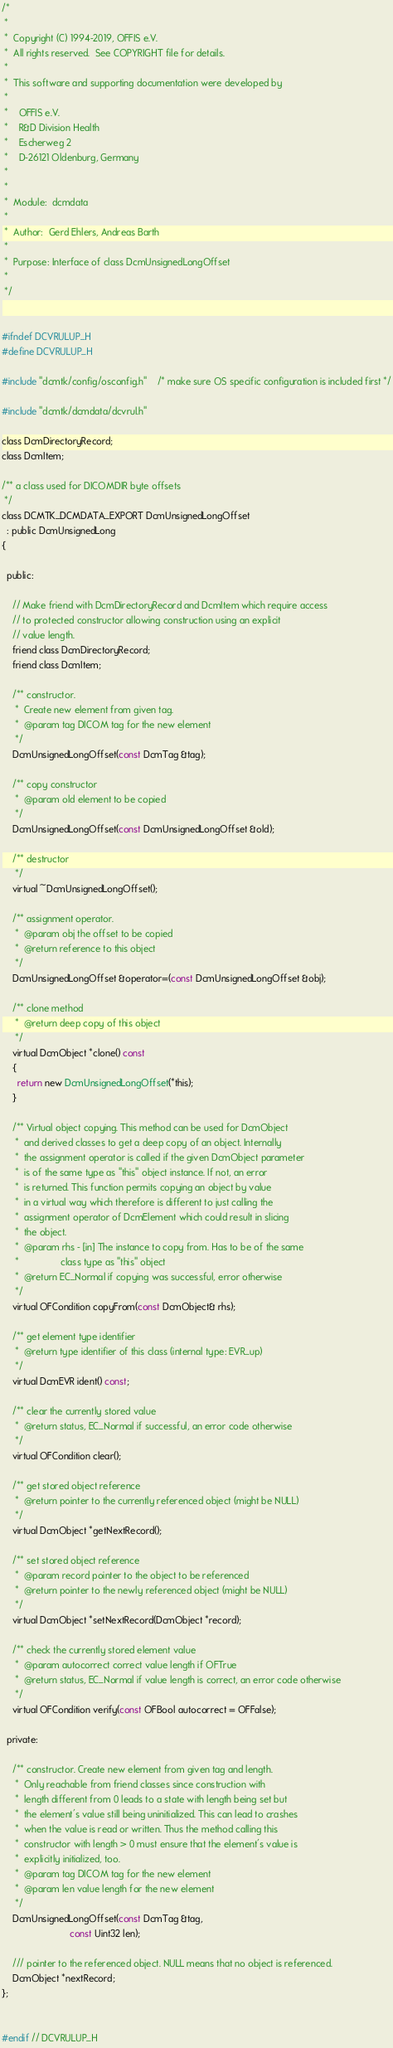<code> <loc_0><loc_0><loc_500><loc_500><_C_>/*
 *
 *  Copyright (C) 1994-2019, OFFIS e.V.
 *  All rights reserved.  See COPYRIGHT file for details.
 *
 *  This software and supporting documentation were developed by
 *
 *    OFFIS e.V.
 *    R&D Division Health
 *    Escherweg 2
 *    D-26121 Oldenburg, Germany
 *
 *
 *  Module:  dcmdata
 *
 *  Author:  Gerd Ehlers, Andreas Barth
 *
 *  Purpose: Interface of class DcmUnsignedLongOffset
 *
 */


#ifndef DCVRULUP_H
#define DCVRULUP_H

#include "dcmtk/config/osconfig.h"    /* make sure OS specific configuration is included first */

#include "dcmtk/dcmdata/dcvrul.h"

class DcmDirectoryRecord;
class DcmItem;

/** a class used for DICOMDIR byte offsets
 */
class DCMTK_DCMDATA_EXPORT DcmUnsignedLongOffset
  : public DcmUnsignedLong
{

  public:

    // Make friend with DcmDirectoryRecord and DcmItem which require access
    // to protected constructor allowing construction using an explicit
    // value length.
    friend class DcmDirectoryRecord;
    friend class DcmItem;

    /** constructor.
     *  Create new element from given tag.
     *  @param tag DICOM tag for the new element
     */
    DcmUnsignedLongOffset(const DcmTag &tag);

    /** copy constructor
     *  @param old element to be copied
     */
    DcmUnsignedLongOffset(const DcmUnsignedLongOffset &old);

    /** destructor
     */
    virtual ~DcmUnsignedLongOffset();

    /** assignment operator.
     *  @param obj the offset to be copied
     *  @return reference to this object
     */
    DcmUnsignedLongOffset &operator=(const DcmUnsignedLongOffset &obj);

    /** clone method
     *  @return deep copy of this object
     */
    virtual DcmObject *clone() const
    {
      return new DcmUnsignedLongOffset(*this);
    }

    /** Virtual object copying. This method can be used for DcmObject
     *  and derived classes to get a deep copy of an object. Internally
     *  the assignment operator is called if the given DcmObject parameter
     *  is of the same type as "this" object instance. If not, an error
     *  is returned. This function permits copying an object by value
     *  in a virtual way which therefore is different to just calling the
     *  assignment operator of DcmElement which could result in slicing
     *  the object.
     *  @param rhs - [in] The instance to copy from. Has to be of the same
     *                class type as "this" object
     *  @return EC_Normal if copying was successful, error otherwise
     */
    virtual OFCondition copyFrom(const DcmObject& rhs);

    /** get element type identifier
     *  @return type identifier of this class (internal type: EVR_up)
     */
    virtual DcmEVR ident() const;

    /** clear the currently stored value
     *  @return status, EC_Normal if successful, an error code otherwise
     */
    virtual OFCondition clear();

    /** get stored object reference
     *  @return pointer to the currently referenced object (might be NULL)
     */
    virtual DcmObject *getNextRecord();

    /** set stored object reference
     *  @param record pointer to the object to be referenced
     *  @return pointer to the newly referenced object (might be NULL)
     */
    virtual DcmObject *setNextRecord(DcmObject *record);

    /** check the currently stored element value
     *  @param autocorrect correct value length if OFTrue
     *  @return status, EC_Normal if value length is correct, an error code otherwise
     */
    virtual OFCondition verify(const OFBool autocorrect = OFFalse);

  private:

    /** constructor. Create new element from given tag and length.
     *  Only reachable from friend classes since construction with
     *  length different from 0 leads to a state with length being set but
     *  the element's value still being uninitialized. This can lead to crashes
     *  when the value is read or written. Thus the method calling this
     *  constructor with length > 0 must ensure that the element's value is
     *  explicitly initialized, too.
     *  @param tag DICOM tag for the new element
     *  @param len value length for the new element
     */
    DcmUnsignedLongOffset(const DcmTag &tag,
                          const Uint32 len);

    /// pointer to the referenced object. NULL means that no object is referenced.
    DcmObject *nextRecord;
};


#endif // DCVRULUP_H
</code> 